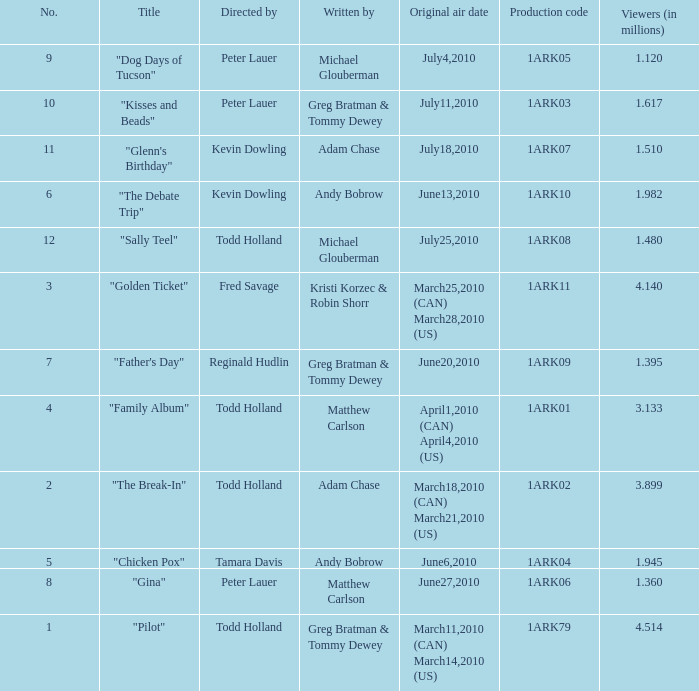Can you parse all the data within this table? {'header': ['No.', 'Title', 'Directed by', 'Written by', 'Original air date', 'Production code', 'Viewers (in millions)'], 'rows': [['9', '"Dog Days of Tucson"', 'Peter Lauer', 'Michael Glouberman', 'July4,2010', '1ARK05', '1.120'], ['10', '"Kisses and Beads"', 'Peter Lauer', 'Greg Bratman & Tommy Dewey', 'July11,2010', '1ARK03', '1.617'], ['11', '"Glenn\'s Birthday"', 'Kevin Dowling', 'Adam Chase', 'July18,2010', '1ARK07', '1.510'], ['6', '"The Debate Trip"', 'Kevin Dowling', 'Andy Bobrow', 'June13,2010', '1ARK10', '1.982'], ['12', '"Sally Teel"', 'Todd Holland', 'Michael Glouberman', 'July25,2010', '1ARK08', '1.480'], ['3', '"Golden Ticket"', 'Fred Savage', 'Kristi Korzec & Robin Shorr', 'March25,2010 (CAN) March28,2010 (US)', '1ARK11', '4.140'], ['7', '"Father\'s Day"', 'Reginald Hudlin', 'Greg Bratman & Tommy Dewey', 'June20,2010', '1ARK09', '1.395'], ['4', '"Family Album"', 'Todd Holland', 'Matthew Carlson', 'April1,2010 (CAN) April4,2010 (US)', '1ARK01', '3.133'], ['2', '"The Break-In"', 'Todd Holland', 'Adam Chase', 'March18,2010 (CAN) March21,2010 (US)', '1ARK02', '3.899'], ['5', '"Chicken Pox"', 'Tamara Davis', 'Andy Bobrow', 'June6,2010', '1ARK04', '1.945'], ['8', '"Gina"', 'Peter Lauer', 'Matthew Carlson', 'June27,2010', '1ARK06', '1.360'], ['1', '"Pilot"', 'Todd Holland', 'Greg Bratman & Tommy Dewey', 'March11,2010 (CAN) March14,2010 (US)', '1ARK79', '4.514']]} What is the original air date for production code 1ark79? March11,2010 (CAN) March14,2010 (US). 